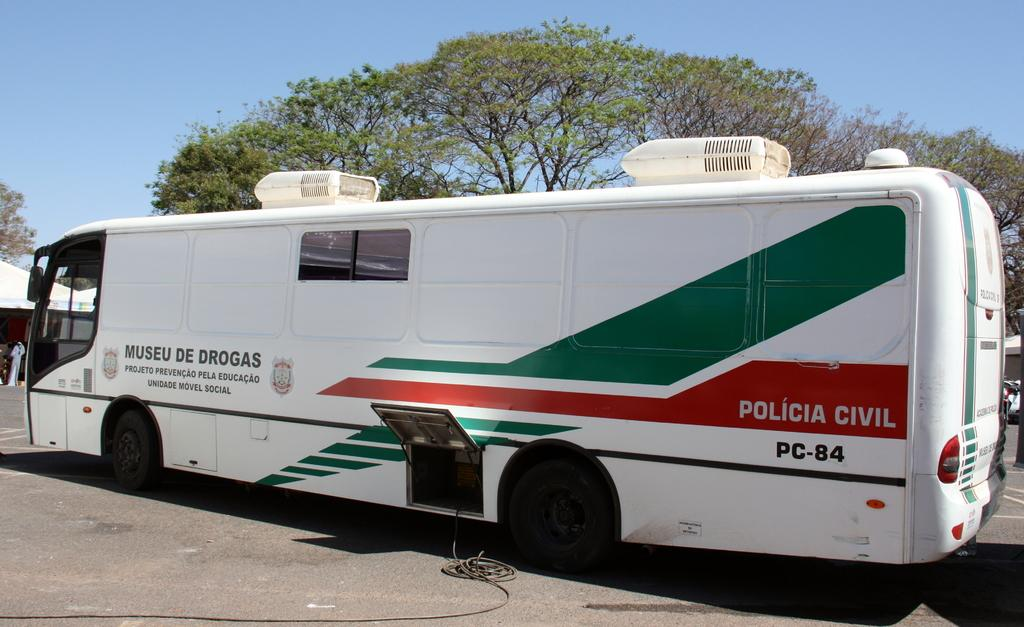What type of motor vehicle can be seen on the road in the image? There is a motor vehicle on the road in the image, but the specific type is not mentioned. What else is visible in the image besides the motor vehicle? There is a cable visible in the image, as well as trees and the sky. Can you describe the natural elements in the image? The image includes trees and the sky. What type of pain is the motor vehicle experiencing in the image? There is no indication of pain in the image, as it features a motor vehicle on the road and other elements. 